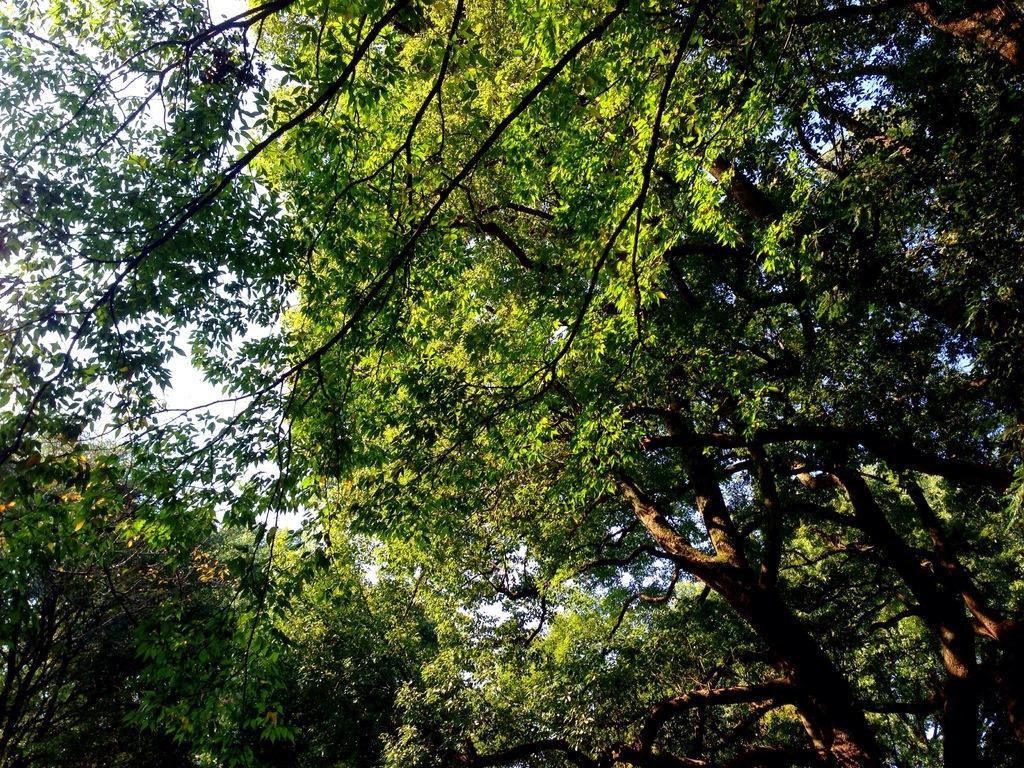Could you give a brief overview of what you see in this image? In this picture we can see trees and in the background we can see the sky. 